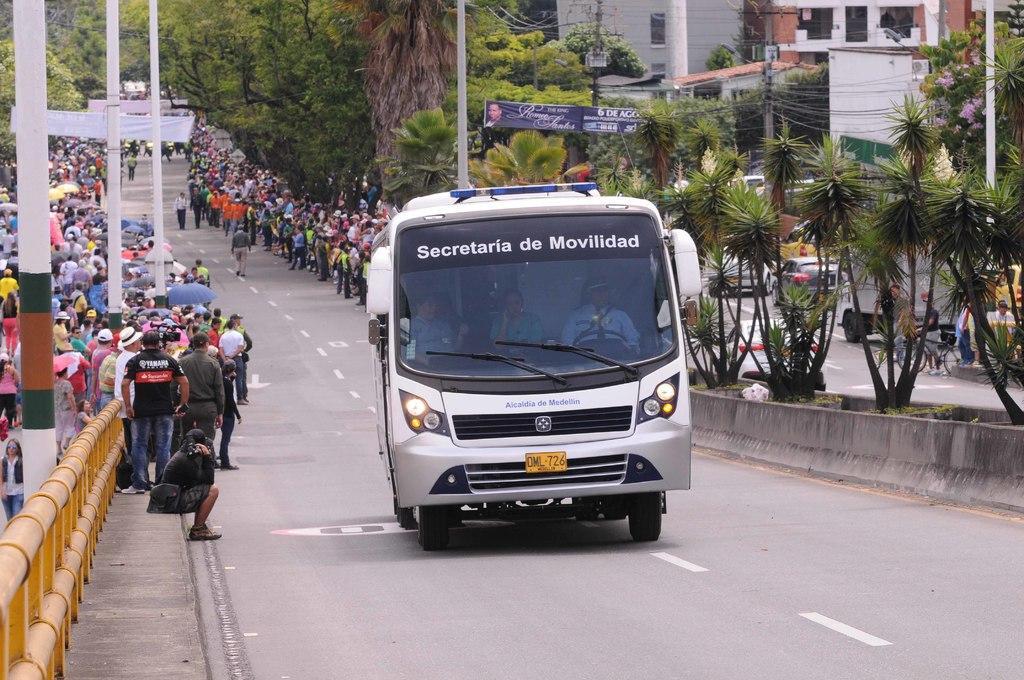Please provide a concise description of this image. In this picture we can see the people and the trees. Few people are walking and few are standing. We can see umbrellas. On the right side of the picture we can see a building, windows,poles, banner, vehicles, person riding a bicycle, people and boards. On the left side of the picture we can see the railing, poles. In the middle portion of the picture we can see the bus and through glass we can see the people. 